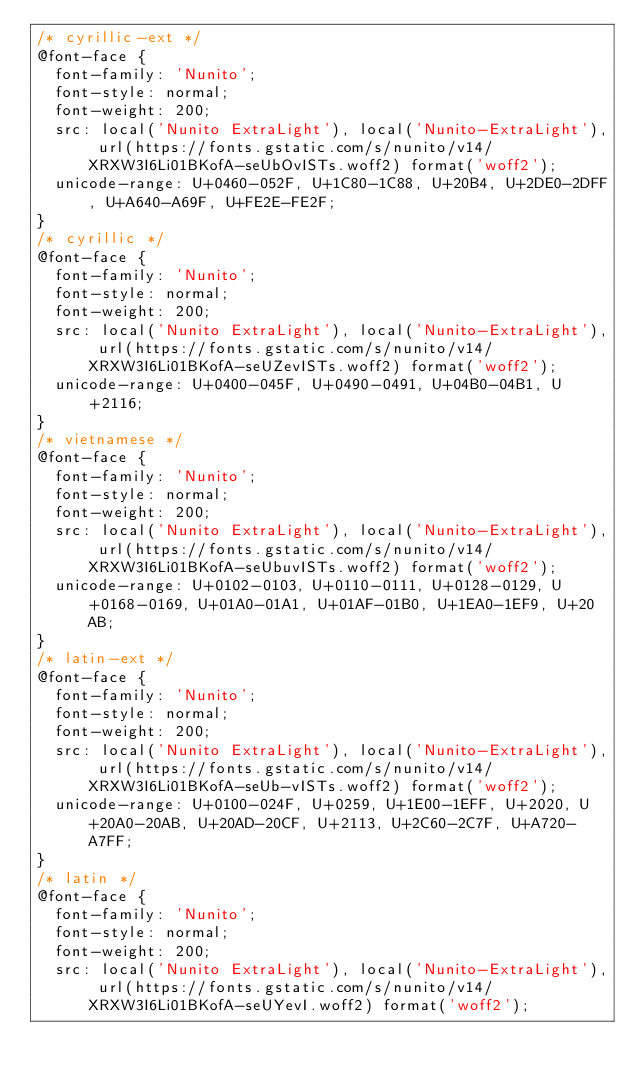<code> <loc_0><loc_0><loc_500><loc_500><_CSS_>/* cyrillic-ext */
@font-face {
  font-family: 'Nunito';
  font-style: normal;
  font-weight: 200;
  src: local('Nunito ExtraLight'), local('Nunito-ExtraLight'), url(https://fonts.gstatic.com/s/nunito/v14/XRXW3I6Li01BKofA-seUbOvISTs.woff2) format('woff2');
  unicode-range: U+0460-052F, U+1C80-1C88, U+20B4, U+2DE0-2DFF, U+A640-A69F, U+FE2E-FE2F;
}
/* cyrillic */
@font-face {
  font-family: 'Nunito';
  font-style: normal;
  font-weight: 200;
  src: local('Nunito ExtraLight'), local('Nunito-ExtraLight'), url(https://fonts.gstatic.com/s/nunito/v14/XRXW3I6Li01BKofA-seUZevISTs.woff2) format('woff2');
  unicode-range: U+0400-045F, U+0490-0491, U+04B0-04B1, U+2116;
}
/* vietnamese */
@font-face {
  font-family: 'Nunito';
  font-style: normal;
  font-weight: 200;
  src: local('Nunito ExtraLight'), local('Nunito-ExtraLight'), url(https://fonts.gstatic.com/s/nunito/v14/XRXW3I6Li01BKofA-seUbuvISTs.woff2) format('woff2');
  unicode-range: U+0102-0103, U+0110-0111, U+0128-0129, U+0168-0169, U+01A0-01A1, U+01AF-01B0, U+1EA0-1EF9, U+20AB;
}
/* latin-ext */
@font-face {
  font-family: 'Nunito';
  font-style: normal;
  font-weight: 200;
  src: local('Nunito ExtraLight'), local('Nunito-ExtraLight'), url(https://fonts.gstatic.com/s/nunito/v14/XRXW3I6Li01BKofA-seUb-vISTs.woff2) format('woff2');
  unicode-range: U+0100-024F, U+0259, U+1E00-1EFF, U+2020, U+20A0-20AB, U+20AD-20CF, U+2113, U+2C60-2C7F, U+A720-A7FF;
}
/* latin */
@font-face {
  font-family: 'Nunito';
  font-style: normal;
  font-weight: 200;
  src: local('Nunito ExtraLight'), local('Nunito-ExtraLight'), url(https://fonts.gstatic.com/s/nunito/v14/XRXW3I6Li01BKofA-seUYevI.woff2) format('woff2');</code> 